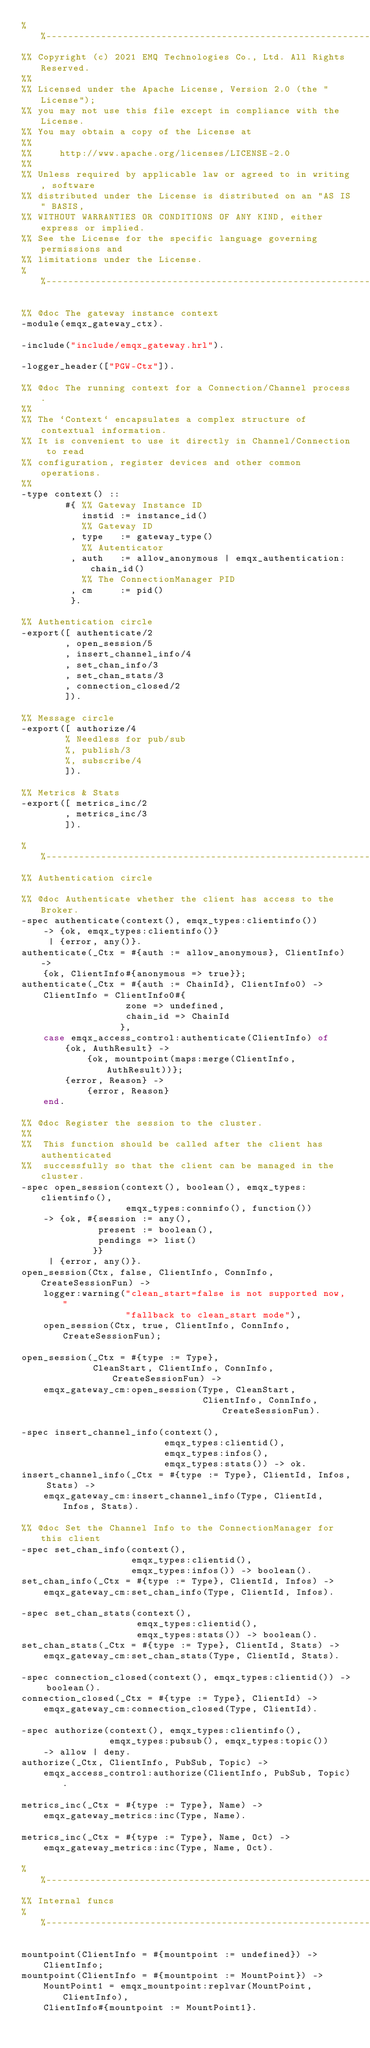Convert code to text. <code><loc_0><loc_0><loc_500><loc_500><_Erlang_>%%--------------------------------------------------------------------
%% Copyright (c) 2021 EMQ Technologies Co., Ltd. All Rights Reserved.
%%
%% Licensed under the Apache License, Version 2.0 (the "License");
%% you may not use this file except in compliance with the License.
%% You may obtain a copy of the License at
%%
%%     http://www.apache.org/licenses/LICENSE-2.0
%%
%% Unless required by applicable law or agreed to in writing, software
%% distributed under the License is distributed on an "AS IS" BASIS,
%% WITHOUT WARRANTIES OR CONDITIONS OF ANY KIND, either express or implied.
%% See the License for the specific language governing permissions and
%% limitations under the License.
%%--------------------------------------------------------------------

%% @doc The gateway instance context
-module(emqx_gateway_ctx).

-include("include/emqx_gateway.hrl").

-logger_header(["PGW-Ctx"]).

%% @doc The running context for a Connection/Channel process.
%%
%% The `Context` encapsulates a complex structure of contextual information.
%% It is convenient to use it directly in Channel/Connection to read
%% configuration, register devices and other common operations.
%%
-type context() ::
        #{ %% Gateway Instance ID
           instid := instance_id()
           %% Gateway ID
         , type   := gateway_type()
           %% Autenticator
         , auth   := allow_anonymous | emqx_authentication:chain_id()
           %% The ConnectionManager PID
         , cm     := pid()
         }.

%% Authentication circle
-export([ authenticate/2
        , open_session/5
        , insert_channel_info/4
        , set_chan_info/3
        , set_chan_stats/3
        , connection_closed/2
        ]).

%% Message circle
-export([ authorize/4
        % Needless for pub/sub
        %, publish/3
        %, subscribe/4
        ]).

%% Metrics & Stats
-export([ metrics_inc/2
        , metrics_inc/3
        ]).

%%--------------------------------------------------------------------
%% Authentication circle

%% @doc Authenticate whether the client has access to the Broker.
-spec authenticate(context(), emqx_types:clientinfo())
    -> {ok, emqx_types:clientinfo()}
     | {error, any()}.
authenticate(_Ctx = #{auth := allow_anonymous}, ClientInfo) ->
    {ok, ClientInfo#{anonymous => true}};
authenticate(_Ctx = #{auth := ChainId}, ClientInfo0) ->
    ClientInfo = ClientInfo0#{
                   zone => undefined,
                   chain_id => ChainId
                  },
    case emqx_access_control:authenticate(ClientInfo) of
        {ok, AuthResult} ->
            {ok, mountpoint(maps:merge(ClientInfo, AuthResult))};
        {error, Reason} ->
            {error, Reason}
    end.

%% @doc Register the session to the cluster.
%%
%%  This function should be called after the client has authenticated
%%  successfully so that the client can be managed in the cluster.
-spec open_session(context(), boolean(), emqx_types:clientinfo(),
                   emqx_types:conninfo(), function())
    -> {ok, #{session := any(),
              present := boolean(),
              pendings => list()
             }}
     | {error, any()}.
open_session(Ctx, false, ClientInfo, ConnInfo, CreateSessionFun) ->
    logger:warning("clean_start=false is not supported now, "
                   "fallback to clean_start mode"),
    open_session(Ctx, true, ClientInfo, ConnInfo, CreateSessionFun);

open_session(_Ctx = #{type := Type},
             CleanStart, ClientInfo, ConnInfo, CreateSessionFun) ->
    emqx_gateway_cm:open_session(Type, CleanStart,
                                 ClientInfo, ConnInfo, CreateSessionFun).

-spec insert_channel_info(context(),
                          emqx_types:clientid(),
                          emqx_types:infos(),
                          emqx_types:stats()) -> ok.
insert_channel_info(_Ctx = #{type := Type}, ClientId, Infos, Stats) ->
    emqx_gateway_cm:insert_channel_info(Type, ClientId, Infos, Stats).

%% @doc Set the Channel Info to the ConnectionManager for this client
-spec set_chan_info(context(),
                    emqx_types:clientid(),
                    emqx_types:infos()) -> boolean().
set_chan_info(_Ctx = #{type := Type}, ClientId, Infos) ->
    emqx_gateway_cm:set_chan_info(Type, ClientId, Infos).

-spec set_chan_stats(context(),
                     emqx_types:clientid(),
                     emqx_types:stats()) -> boolean().
set_chan_stats(_Ctx = #{type := Type}, ClientId, Stats) ->
    emqx_gateway_cm:set_chan_stats(Type, ClientId, Stats).

-spec connection_closed(context(), emqx_types:clientid()) -> boolean().
connection_closed(_Ctx = #{type := Type}, ClientId) ->
    emqx_gateway_cm:connection_closed(Type, ClientId).

-spec authorize(context(), emqx_types:clientinfo(),
                emqx_types:pubsub(), emqx_types:topic())
    -> allow | deny.
authorize(_Ctx, ClientInfo, PubSub, Topic) ->
    emqx_access_control:authorize(ClientInfo, PubSub, Topic).

metrics_inc(_Ctx = #{type := Type}, Name) ->
    emqx_gateway_metrics:inc(Type, Name).

metrics_inc(_Ctx = #{type := Type}, Name, Oct) ->
    emqx_gateway_metrics:inc(Type, Name, Oct).

%%--------------------------------------------------------------------
%% Internal funcs
%%--------------------------------------------------------------------

mountpoint(ClientInfo = #{mountpoint := undefined}) ->
    ClientInfo;
mountpoint(ClientInfo = #{mountpoint := MountPoint}) ->
    MountPoint1 = emqx_mountpoint:replvar(MountPoint, ClientInfo),
    ClientInfo#{mountpoint := MountPoint1}.
</code> 